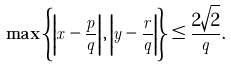<formula> <loc_0><loc_0><loc_500><loc_500>\max \left \{ \left | x - \frac { p } { q } \right | , \left | y - \frac { r } { q } \right | \right \} \leq \frac { 2 \sqrt { 2 } } { q } .</formula> 